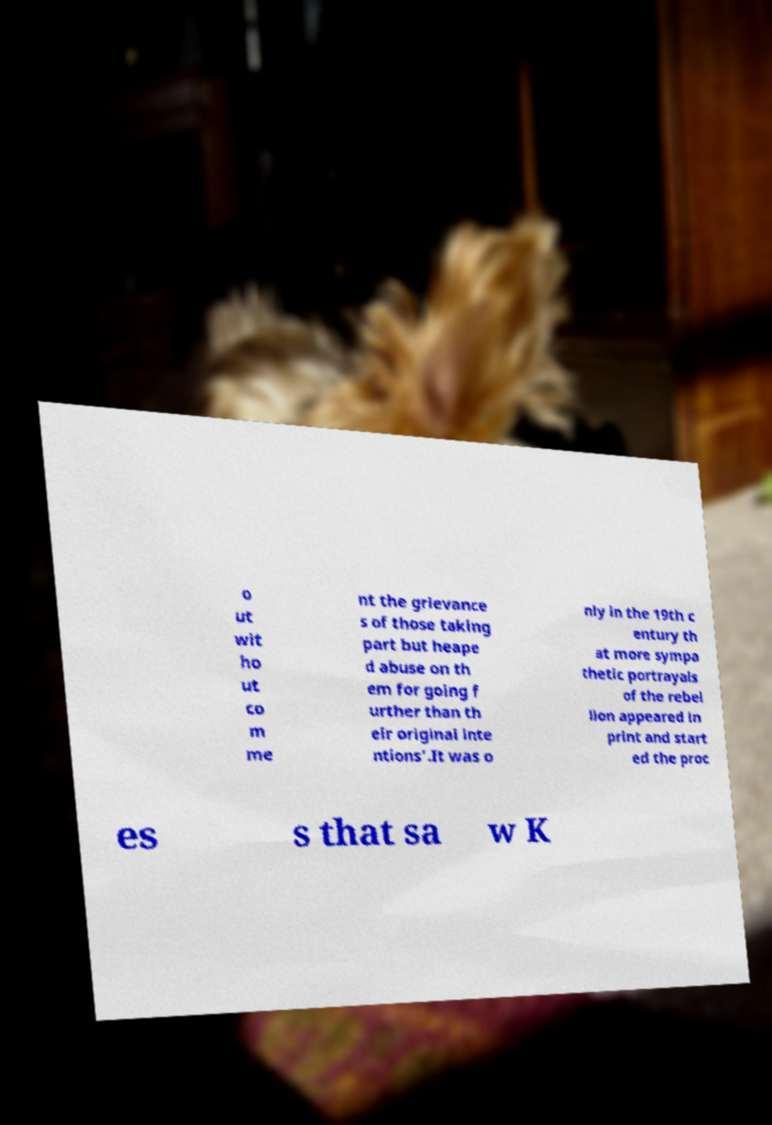Please identify and transcribe the text found in this image. o ut wit ho ut co m me nt the grievance s of those taking part but heape d abuse on th em for going f urther than th eir original inte ntions'.It was o nly in the 19th c entury th at more sympa thetic portrayals of the rebel lion appeared in print and start ed the proc es s that sa w K 